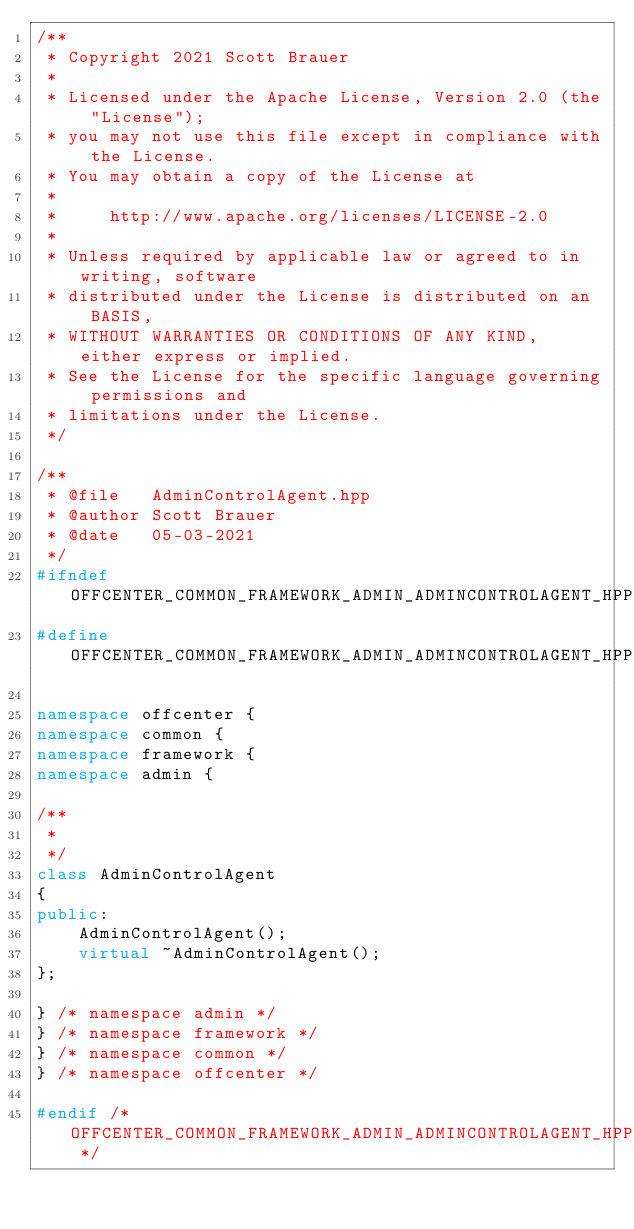Convert code to text. <code><loc_0><loc_0><loc_500><loc_500><_C++_>/**
 * Copyright 2021 Scott Brauer
 *
 * Licensed under the Apache License, Version 2.0 (the "License");
 * you may not use this file except in compliance with the License.
 * You may obtain a copy of the License at
 *
 *     http://www.apache.org/licenses/LICENSE-2.0
 *
 * Unless required by applicable law or agreed to in writing, software
 * distributed under the License is distributed on an  BASIS,
 * WITHOUT WARRANTIES OR CONDITIONS OF ANY KIND, either express or implied.
 * See the License for the specific language governing permissions and
 * limitations under the License.
 */

/**
 * @file   AdminControlAgent.hpp
 * @author Scott Brauer
 * @date   05-03-2021
 */
#ifndef OFFCENTER_COMMON_FRAMEWORK_ADMIN_ADMINCONTROLAGENT_HPP_
#define OFFCENTER_COMMON_FRAMEWORK_ADMIN_ADMINCONTROLAGENT_HPP_

namespace offcenter {
namespace common {
namespace framework {
namespace admin {

/**
 *
 */
class AdminControlAgent
{
public:
	AdminControlAgent();
	virtual ~AdminControlAgent();
};

} /* namespace admin */
} /* namespace framework */
} /* namespace common */
} /* namespace offcenter */

#endif /* OFFCENTER_COMMON_FRAMEWORK_ADMIN_ADMINCONTROLAGENT_HPP_ */
</code> 